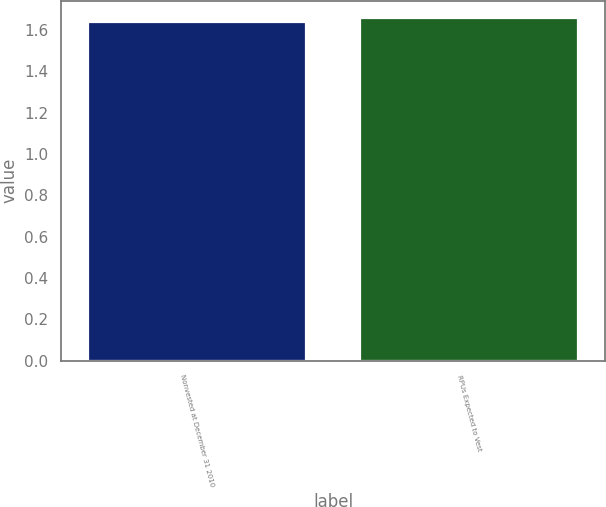Convert chart. <chart><loc_0><loc_0><loc_500><loc_500><bar_chart><fcel>Nonvested at December 31 2010<fcel>RPUs Expected to Vest<nl><fcel>1.64<fcel>1.66<nl></chart> 